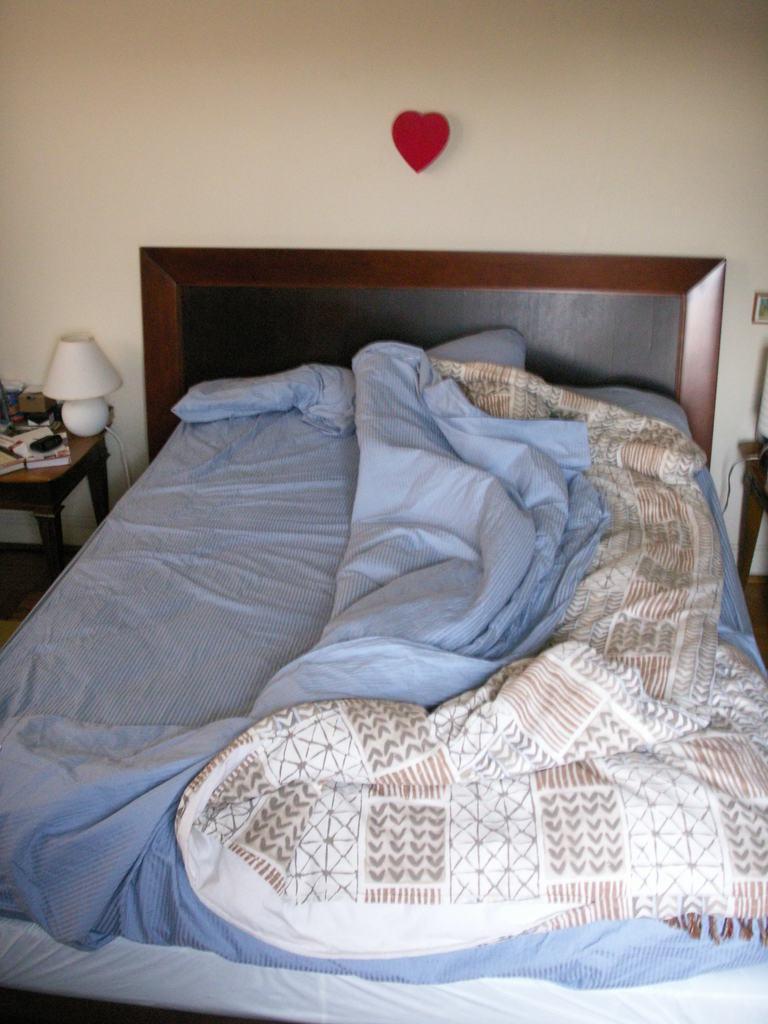Please provide a concise description of this image. In this image, we can see a bed. On top of that there is a blanket and pillow. On the left side and right side of the image, we can see tables, some objects. Background we can see heart on the wall. 